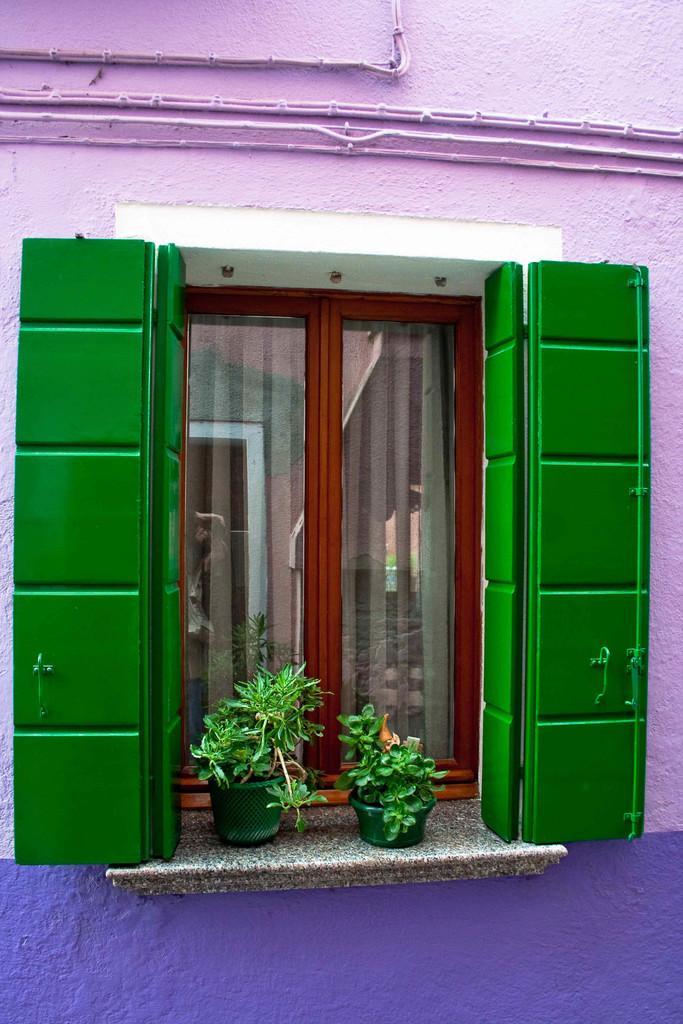In one or two sentences, can you explain what this image depicts? In this picture we can see a wall and a window, there are two plants and a glass door in the middle. 